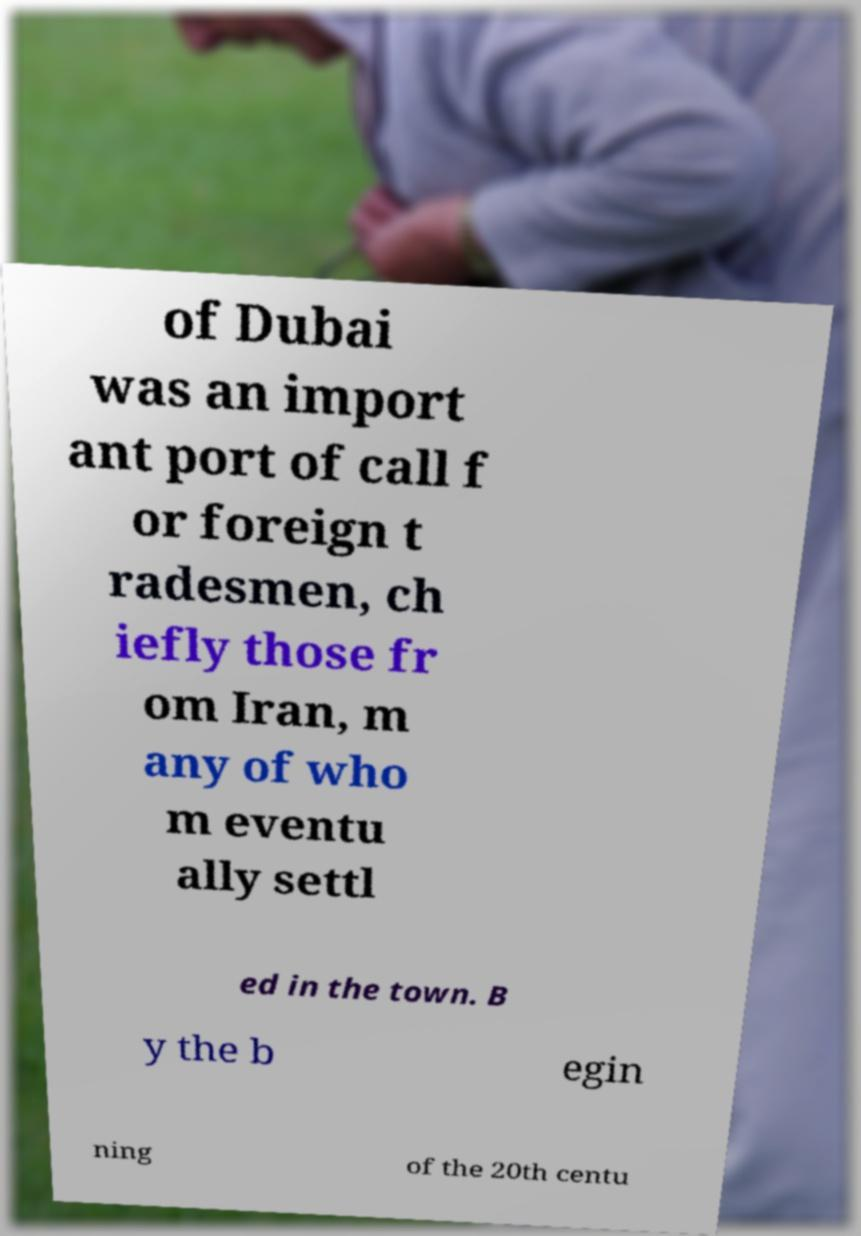There's text embedded in this image that I need extracted. Can you transcribe it verbatim? of Dubai was an import ant port of call f or foreign t radesmen, ch iefly those fr om Iran, m any of who m eventu ally settl ed in the town. B y the b egin ning of the 20th centu 